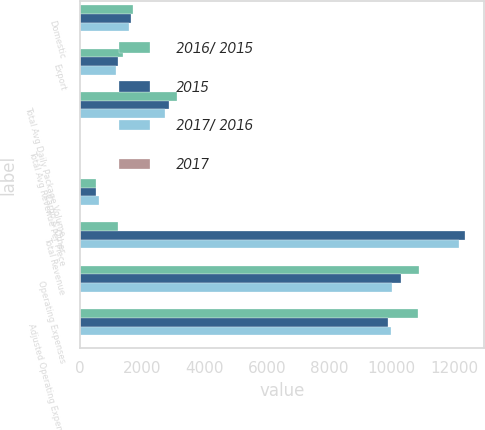Convert chart. <chart><loc_0><loc_0><loc_500><loc_500><stacked_bar_chart><ecel><fcel>Domestic<fcel>Export<fcel>Total Avg Daily Package Volume<fcel>Total Avg Revenue Per Piece<fcel>Cargo & Other<fcel>Total Revenue<fcel>Operating Expenses<fcel>Adjusted Operating Expenses<nl><fcel>2016/ 2015<fcel>1714<fcel>1395<fcel>3109<fcel>16.22<fcel>526<fcel>1210<fcel>10874<fcel>10839<nl><fcel>2015<fcel>1635<fcel>1210<fcel>2845<fcel>16.29<fcel>535<fcel>12350<fcel>10306<fcel>9881<nl><fcel>2017/ 2016<fcel>1575<fcel>1151<fcel>2726<fcel>16.63<fcel>632<fcel>12149<fcel>10012<fcel>9968<nl><fcel>2017<fcel>4.8<fcel>15.3<fcel>9.3<fcel>0.4<fcel>1.7<fcel>8<fcel>5.5<fcel>9.7<nl></chart> 